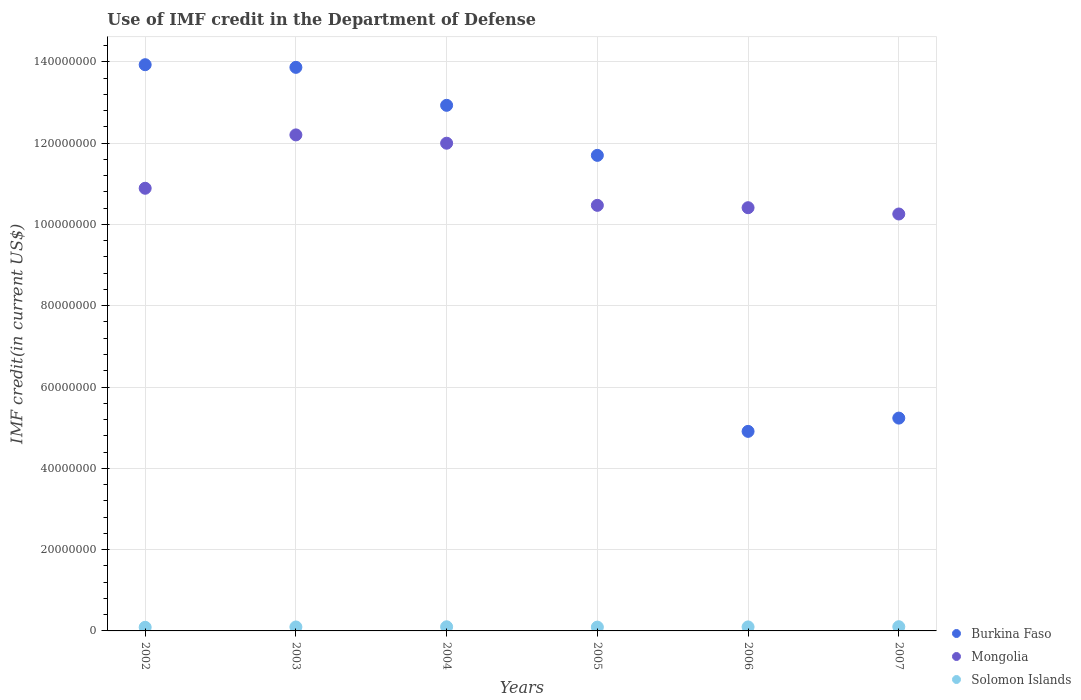What is the IMF credit in the Department of Defense in Solomon Islands in 2005?
Make the answer very short. 9.35e+05. Across all years, what is the maximum IMF credit in the Department of Defense in Burkina Faso?
Make the answer very short. 1.39e+08. Across all years, what is the minimum IMF credit in the Department of Defense in Burkina Faso?
Make the answer very short. 4.91e+07. In which year was the IMF credit in the Department of Defense in Mongolia maximum?
Give a very brief answer. 2003. In which year was the IMF credit in the Department of Defense in Burkina Faso minimum?
Offer a terse response. 2006. What is the total IMF credit in the Department of Defense in Solomon Islands in the graph?
Your answer should be very brief. 5.83e+06. What is the difference between the IMF credit in the Department of Defense in Mongolia in 2003 and that in 2006?
Make the answer very short. 1.79e+07. What is the difference between the IMF credit in the Department of Defense in Mongolia in 2006 and the IMF credit in the Department of Defense in Burkina Faso in 2005?
Your response must be concise. -1.29e+07. What is the average IMF credit in the Department of Defense in Burkina Faso per year?
Provide a succinct answer. 1.04e+08. In the year 2003, what is the difference between the IMF credit in the Department of Defense in Mongolia and IMF credit in the Department of Defense in Burkina Faso?
Offer a terse response. -1.66e+07. What is the ratio of the IMF credit in the Department of Defense in Solomon Islands in 2003 to that in 2007?
Your response must be concise. 0.94. Is the difference between the IMF credit in the Department of Defense in Mongolia in 2006 and 2007 greater than the difference between the IMF credit in the Department of Defense in Burkina Faso in 2006 and 2007?
Provide a short and direct response. Yes. What is the difference between the highest and the second highest IMF credit in the Department of Defense in Mongolia?
Your answer should be very brief. 2.04e+06. What is the difference between the highest and the lowest IMF credit in the Department of Defense in Burkina Faso?
Your response must be concise. 9.02e+07. Is the sum of the IMF credit in the Department of Defense in Solomon Islands in 2003 and 2004 greater than the maximum IMF credit in the Department of Defense in Burkina Faso across all years?
Provide a succinct answer. No. Is the IMF credit in the Department of Defense in Solomon Islands strictly greater than the IMF credit in the Department of Defense in Burkina Faso over the years?
Your answer should be compact. No. How many dotlines are there?
Offer a terse response. 3. How many years are there in the graph?
Make the answer very short. 6. Are the values on the major ticks of Y-axis written in scientific E-notation?
Keep it short and to the point. No. Does the graph contain grids?
Give a very brief answer. Yes. Where does the legend appear in the graph?
Your response must be concise. Bottom right. How many legend labels are there?
Offer a terse response. 3. What is the title of the graph?
Ensure brevity in your answer.  Use of IMF credit in the Department of Defense. Does "Cyprus" appear as one of the legend labels in the graph?
Provide a short and direct response. No. What is the label or title of the X-axis?
Keep it short and to the point. Years. What is the label or title of the Y-axis?
Offer a terse response. IMF credit(in current US$). What is the IMF credit(in current US$) of Burkina Faso in 2002?
Ensure brevity in your answer.  1.39e+08. What is the IMF credit(in current US$) of Mongolia in 2002?
Offer a terse response. 1.09e+08. What is the IMF credit(in current US$) in Solomon Islands in 2002?
Provide a succinct answer. 8.90e+05. What is the IMF credit(in current US$) of Burkina Faso in 2003?
Offer a terse response. 1.39e+08. What is the IMF credit(in current US$) in Mongolia in 2003?
Provide a succinct answer. 1.22e+08. What is the IMF credit(in current US$) in Solomon Islands in 2003?
Your answer should be compact. 9.72e+05. What is the IMF credit(in current US$) of Burkina Faso in 2004?
Make the answer very short. 1.29e+08. What is the IMF credit(in current US$) in Mongolia in 2004?
Your response must be concise. 1.20e+08. What is the IMF credit(in current US$) of Solomon Islands in 2004?
Your response must be concise. 1.02e+06. What is the IMF credit(in current US$) of Burkina Faso in 2005?
Make the answer very short. 1.17e+08. What is the IMF credit(in current US$) of Mongolia in 2005?
Offer a very short reply. 1.05e+08. What is the IMF credit(in current US$) in Solomon Islands in 2005?
Provide a succinct answer. 9.35e+05. What is the IMF credit(in current US$) in Burkina Faso in 2006?
Your response must be concise. 4.91e+07. What is the IMF credit(in current US$) in Mongolia in 2006?
Your answer should be compact. 1.04e+08. What is the IMF credit(in current US$) of Solomon Islands in 2006?
Make the answer very short. 9.84e+05. What is the IMF credit(in current US$) in Burkina Faso in 2007?
Your answer should be compact. 5.24e+07. What is the IMF credit(in current US$) of Mongolia in 2007?
Your answer should be compact. 1.03e+08. What is the IMF credit(in current US$) of Solomon Islands in 2007?
Your answer should be very brief. 1.03e+06. Across all years, what is the maximum IMF credit(in current US$) of Burkina Faso?
Your answer should be compact. 1.39e+08. Across all years, what is the maximum IMF credit(in current US$) in Mongolia?
Your answer should be compact. 1.22e+08. Across all years, what is the maximum IMF credit(in current US$) of Solomon Islands?
Provide a short and direct response. 1.03e+06. Across all years, what is the minimum IMF credit(in current US$) of Burkina Faso?
Provide a short and direct response. 4.91e+07. Across all years, what is the minimum IMF credit(in current US$) in Mongolia?
Your response must be concise. 1.03e+08. Across all years, what is the minimum IMF credit(in current US$) of Solomon Islands?
Give a very brief answer. 8.90e+05. What is the total IMF credit(in current US$) in Burkina Faso in the graph?
Offer a very short reply. 6.26e+08. What is the total IMF credit(in current US$) of Mongolia in the graph?
Provide a short and direct response. 6.62e+08. What is the total IMF credit(in current US$) in Solomon Islands in the graph?
Offer a terse response. 5.83e+06. What is the difference between the IMF credit(in current US$) of Burkina Faso in 2002 and that in 2003?
Ensure brevity in your answer.  6.52e+05. What is the difference between the IMF credit(in current US$) in Mongolia in 2002 and that in 2003?
Provide a succinct answer. -1.31e+07. What is the difference between the IMF credit(in current US$) of Solomon Islands in 2002 and that in 2003?
Offer a very short reply. -8.20e+04. What is the difference between the IMF credit(in current US$) in Burkina Faso in 2002 and that in 2004?
Provide a succinct answer. 9.99e+06. What is the difference between the IMF credit(in current US$) of Mongolia in 2002 and that in 2004?
Make the answer very short. -1.11e+07. What is the difference between the IMF credit(in current US$) in Solomon Islands in 2002 and that in 2004?
Your answer should be compact. -1.26e+05. What is the difference between the IMF credit(in current US$) in Burkina Faso in 2002 and that in 2005?
Your answer should be compact. 2.23e+07. What is the difference between the IMF credit(in current US$) of Mongolia in 2002 and that in 2005?
Ensure brevity in your answer.  4.20e+06. What is the difference between the IMF credit(in current US$) in Solomon Islands in 2002 and that in 2005?
Your answer should be very brief. -4.50e+04. What is the difference between the IMF credit(in current US$) of Burkina Faso in 2002 and that in 2006?
Provide a short and direct response. 9.02e+07. What is the difference between the IMF credit(in current US$) of Mongolia in 2002 and that in 2006?
Ensure brevity in your answer.  4.78e+06. What is the difference between the IMF credit(in current US$) of Solomon Islands in 2002 and that in 2006?
Give a very brief answer. -9.40e+04. What is the difference between the IMF credit(in current US$) of Burkina Faso in 2002 and that in 2007?
Keep it short and to the point. 8.69e+07. What is the difference between the IMF credit(in current US$) in Mongolia in 2002 and that in 2007?
Ensure brevity in your answer.  6.33e+06. What is the difference between the IMF credit(in current US$) in Solomon Islands in 2002 and that in 2007?
Ensure brevity in your answer.  -1.44e+05. What is the difference between the IMF credit(in current US$) of Burkina Faso in 2003 and that in 2004?
Give a very brief answer. 9.34e+06. What is the difference between the IMF credit(in current US$) in Mongolia in 2003 and that in 2004?
Ensure brevity in your answer.  2.04e+06. What is the difference between the IMF credit(in current US$) in Solomon Islands in 2003 and that in 2004?
Make the answer very short. -4.40e+04. What is the difference between the IMF credit(in current US$) of Burkina Faso in 2003 and that in 2005?
Make the answer very short. 2.17e+07. What is the difference between the IMF credit(in current US$) in Mongolia in 2003 and that in 2005?
Your response must be concise. 1.73e+07. What is the difference between the IMF credit(in current US$) in Solomon Islands in 2003 and that in 2005?
Your answer should be very brief. 3.70e+04. What is the difference between the IMF credit(in current US$) of Burkina Faso in 2003 and that in 2006?
Keep it short and to the point. 8.95e+07. What is the difference between the IMF credit(in current US$) in Mongolia in 2003 and that in 2006?
Your response must be concise. 1.79e+07. What is the difference between the IMF credit(in current US$) of Solomon Islands in 2003 and that in 2006?
Your answer should be very brief. -1.20e+04. What is the difference between the IMF credit(in current US$) of Burkina Faso in 2003 and that in 2007?
Offer a very short reply. 8.63e+07. What is the difference between the IMF credit(in current US$) of Mongolia in 2003 and that in 2007?
Keep it short and to the point. 1.95e+07. What is the difference between the IMF credit(in current US$) of Solomon Islands in 2003 and that in 2007?
Make the answer very short. -6.20e+04. What is the difference between the IMF credit(in current US$) of Burkina Faso in 2004 and that in 2005?
Your response must be concise. 1.23e+07. What is the difference between the IMF credit(in current US$) of Mongolia in 2004 and that in 2005?
Provide a succinct answer. 1.53e+07. What is the difference between the IMF credit(in current US$) in Solomon Islands in 2004 and that in 2005?
Your response must be concise. 8.10e+04. What is the difference between the IMF credit(in current US$) of Burkina Faso in 2004 and that in 2006?
Keep it short and to the point. 8.02e+07. What is the difference between the IMF credit(in current US$) of Mongolia in 2004 and that in 2006?
Make the answer very short. 1.59e+07. What is the difference between the IMF credit(in current US$) in Solomon Islands in 2004 and that in 2006?
Keep it short and to the point. 3.20e+04. What is the difference between the IMF credit(in current US$) of Burkina Faso in 2004 and that in 2007?
Keep it short and to the point. 7.69e+07. What is the difference between the IMF credit(in current US$) of Mongolia in 2004 and that in 2007?
Offer a very short reply. 1.74e+07. What is the difference between the IMF credit(in current US$) in Solomon Islands in 2004 and that in 2007?
Provide a succinct answer. -1.80e+04. What is the difference between the IMF credit(in current US$) of Burkina Faso in 2005 and that in 2006?
Provide a succinct answer. 6.79e+07. What is the difference between the IMF credit(in current US$) of Mongolia in 2005 and that in 2006?
Your answer should be compact. 5.81e+05. What is the difference between the IMF credit(in current US$) of Solomon Islands in 2005 and that in 2006?
Your answer should be compact. -4.90e+04. What is the difference between the IMF credit(in current US$) in Burkina Faso in 2005 and that in 2007?
Make the answer very short. 6.46e+07. What is the difference between the IMF credit(in current US$) in Mongolia in 2005 and that in 2007?
Offer a very short reply. 2.13e+06. What is the difference between the IMF credit(in current US$) in Solomon Islands in 2005 and that in 2007?
Keep it short and to the point. -9.90e+04. What is the difference between the IMF credit(in current US$) of Burkina Faso in 2006 and that in 2007?
Offer a terse response. -3.27e+06. What is the difference between the IMF credit(in current US$) of Mongolia in 2006 and that in 2007?
Your response must be concise. 1.55e+06. What is the difference between the IMF credit(in current US$) in Burkina Faso in 2002 and the IMF credit(in current US$) in Mongolia in 2003?
Provide a short and direct response. 1.73e+07. What is the difference between the IMF credit(in current US$) in Burkina Faso in 2002 and the IMF credit(in current US$) in Solomon Islands in 2003?
Ensure brevity in your answer.  1.38e+08. What is the difference between the IMF credit(in current US$) of Mongolia in 2002 and the IMF credit(in current US$) of Solomon Islands in 2003?
Keep it short and to the point. 1.08e+08. What is the difference between the IMF credit(in current US$) in Burkina Faso in 2002 and the IMF credit(in current US$) in Mongolia in 2004?
Provide a succinct answer. 1.93e+07. What is the difference between the IMF credit(in current US$) in Burkina Faso in 2002 and the IMF credit(in current US$) in Solomon Islands in 2004?
Make the answer very short. 1.38e+08. What is the difference between the IMF credit(in current US$) in Mongolia in 2002 and the IMF credit(in current US$) in Solomon Islands in 2004?
Your response must be concise. 1.08e+08. What is the difference between the IMF credit(in current US$) of Burkina Faso in 2002 and the IMF credit(in current US$) of Mongolia in 2005?
Keep it short and to the point. 3.46e+07. What is the difference between the IMF credit(in current US$) in Burkina Faso in 2002 and the IMF credit(in current US$) in Solomon Islands in 2005?
Offer a terse response. 1.38e+08. What is the difference between the IMF credit(in current US$) in Mongolia in 2002 and the IMF credit(in current US$) in Solomon Islands in 2005?
Your answer should be very brief. 1.08e+08. What is the difference between the IMF credit(in current US$) in Burkina Faso in 2002 and the IMF credit(in current US$) in Mongolia in 2006?
Your answer should be compact. 3.52e+07. What is the difference between the IMF credit(in current US$) in Burkina Faso in 2002 and the IMF credit(in current US$) in Solomon Islands in 2006?
Your response must be concise. 1.38e+08. What is the difference between the IMF credit(in current US$) in Mongolia in 2002 and the IMF credit(in current US$) in Solomon Islands in 2006?
Make the answer very short. 1.08e+08. What is the difference between the IMF credit(in current US$) of Burkina Faso in 2002 and the IMF credit(in current US$) of Mongolia in 2007?
Your response must be concise. 3.67e+07. What is the difference between the IMF credit(in current US$) of Burkina Faso in 2002 and the IMF credit(in current US$) of Solomon Islands in 2007?
Offer a very short reply. 1.38e+08. What is the difference between the IMF credit(in current US$) of Mongolia in 2002 and the IMF credit(in current US$) of Solomon Islands in 2007?
Your response must be concise. 1.08e+08. What is the difference between the IMF credit(in current US$) of Burkina Faso in 2003 and the IMF credit(in current US$) of Mongolia in 2004?
Make the answer very short. 1.87e+07. What is the difference between the IMF credit(in current US$) of Burkina Faso in 2003 and the IMF credit(in current US$) of Solomon Islands in 2004?
Make the answer very short. 1.38e+08. What is the difference between the IMF credit(in current US$) in Mongolia in 2003 and the IMF credit(in current US$) in Solomon Islands in 2004?
Keep it short and to the point. 1.21e+08. What is the difference between the IMF credit(in current US$) in Burkina Faso in 2003 and the IMF credit(in current US$) in Mongolia in 2005?
Your answer should be compact. 3.39e+07. What is the difference between the IMF credit(in current US$) in Burkina Faso in 2003 and the IMF credit(in current US$) in Solomon Islands in 2005?
Your answer should be very brief. 1.38e+08. What is the difference between the IMF credit(in current US$) of Mongolia in 2003 and the IMF credit(in current US$) of Solomon Islands in 2005?
Your answer should be very brief. 1.21e+08. What is the difference between the IMF credit(in current US$) of Burkina Faso in 2003 and the IMF credit(in current US$) of Mongolia in 2006?
Your answer should be very brief. 3.45e+07. What is the difference between the IMF credit(in current US$) in Burkina Faso in 2003 and the IMF credit(in current US$) in Solomon Islands in 2006?
Your answer should be very brief. 1.38e+08. What is the difference between the IMF credit(in current US$) in Mongolia in 2003 and the IMF credit(in current US$) in Solomon Islands in 2006?
Offer a terse response. 1.21e+08. What is the difference between the IMF credit(in current US$) in Burkina Faso in 2003 and the IMF credit(in current US$) in Mongolia in 2007?
Provide a short and direct response. 3.61e+07. What is the difference between the IMF credit(in current US$) in Burkina Faso in 2003 and the IMF credit(in current US$) in Solomon Islands in 2007?
Provide a short and direct response. 1.38e+08. What is the difference between the IMF credit(in current US$) of Mongolia in 2003 and the IMF credit(in current US$) of Solomon Islands in 2007?
Offer a terse response. 1.21e+08. What is the difference between the IMF credit(in current US$) in Burkina Faso in 2004 and the IMF credit(in current US$) in Mongolia in 2005?
Your answer should be very brief. 2.46e+07. What is the difference between the IMF credit(in current US$) of Burkina Faso in 2004 and the IMF credit(in current US$) of Solomon Islands in 2005?
Offer a terse response. 1.28e+08. What is the difference between the IMF credit(in current US$) in Mongolia in 2004 and the IMF credit(in current US$) in Solomon Islands in 2005?
Provide a short and direct response. 1.19e+08. What is the difference between the IMF credit(in current US$) of Burkina Faso in 2004 and the IMF credit(in current US$) of Mongolia in 2006?
Offer a very short reply. 2.52e+07. What is the difference between the IMF credit(in current US$) in Burkina Faso in 2004 and the IMF credit(in current US$) in Solomon Islands in 2006?
Provide a short and direct response. 1.28e+08. What is the difference between the IMF credit(in current US$) of Mongolia in 2004 and the IMF credit(in current US$) of Solomon Islands in 2006?
Keep it short and to the point. 1.19e+08. What is the difference between the IMF credit(in current US$) in Burkina Faso in 2004 and the IMF credit(in current US$) in Mongolia in 2007?
Make the answer very short. 2.67e+07. What is the difference between the IMF credit(in current US$) of Burkina Faso in 2004 and the IMF credit(in current US$) of Solomon Islands in 2007?
Provide a short and direct response. 1.28e+08. What is the difference between the IMF credit(in current US$) of Mongolia in 2004 and the IMF credit(in current US$) of Solomon Islands in 2007?
Your response must be concise. 1.19e+08. What is the difference between the IMF credit(in current US$) of Burkina Faso in 2005 and the IMF credit(in current US$) of Mongolia in 2006?
Provide a short and direct response. 1.29e+07. What is the difference between the IMF credit(in current US$) of Burkina Faso in 2005 and the IMF credit(in current US$) of Solomon Islands in 2006?
Offer a terse response. 1.16e+08. What is the difference between the IMF credit(in current US$) of Mongolia in 2005 and the IMF credit(in current US$) of Solomon Islands in 2006?
Offer a terse response. 1.04e+08. What is the difference between the IMF credit(in current US$) of Burkina Faso in 2005 and the IMF credit(in current US$) of Mongolia in 2007?
Your answer should be very brief. 1.44e+07. What is the difference between the IMF credit(in current US$) of Burkina Faso in 2005 and the IMF credit(in current US$) of Solomon Islands in 2007?
Offer a very short reply. 1.16e+08. What is the difference between the IMF credit(in current US$) in Mongolia in 2005 and the IMF credit(in current US$) in Solomon Islands in 2007?
Provide a succinct answer. 1.04e+08. What is the difference between the IMF credit(in current US$) of Burkina Faso in 2006 and the IMF credit(in current US$) of Mongolia in 2007?
Offer a very short reply. -5.35e+07. What is the difference between the IMF credit(in current US$) in Burkina Faso in 2006 and the IMF credit(in current US$) in Solomon Islands in 2007?
Make the answer very short. 4.81e+07. What is the difference between the IMF credit(in current US$) of Mongolia in 2006 and the IMF credit(in current US$) of Solomon Islands in 2007?
Your response must be concise. 1.03e+08. What is the average IMF credit(in current US$) in Burkina Faso per year?
Offer a very short reply. 1.04e+08. What is the average IMF credit(in current US$) in Mongolia per year?
Your answer should be compact. 1.10e+08. What is the average IMF credit(in current US$) in Solomon Islands per year?
Keep it short and to the point. 9.72e+05. In the year 2002, what is the difference between the IMF credit(in current US$) of Burkina Faso and IMF credit(in current US$) of Mongolia?
Give a very brief answer. 3.04e+07. In the year 2002, what is the difference between the IMF credit(in current US$) in Burkina Faso and IMF credit(in current US$) in Solomon Islands?
Keep it short and to the point. 1.38e+08. In the year 2002, what is the difference between the IMF credit(in current US$) in Mongolia and IMF credit(in current US$) in Solomon Islands?
Give a very brief answer. 1.08e+08. In the year 2003, what is the difference between the IMF credit(in current US$) of Burkina Faso and IMF credit(in current US$) of Mongolia?
Your response must be concise. 1.66e+07. In the year 2003, what is the difference between the IMF credit(in current US$) in Burkina Faso and IMF credit(in current US$) in Solomon Islands?
Give a very brief answer. 1.38e+08. In the year 2003, what is the difference between the IMF credit(in current US$) of Mongolia and IMF credit(in current US$) of Solomon Islands?
Keep it short and to the point. 1.21e+08. In the year 2004, what is the difference between the IMF credit(in current US$) in Burkina Faso and IMF credit(in current US$) in Mongolia?
Make the answer very short. 9.32e+06. In the year 2004, what is the difference between the IMF credit(in current US$) of Burkina Faso and IMF credit(in current US$) of Solomon Islands?
Offer a terse response. 1.28e+08. In the year 2004, what is the difference between the IMF credit(in current US$) of Mongolia and IMF credit(in current US$) of Solomon Islands?
Your answer should be compact. 1.19e+08. In the year 2005, what is the difference between the IMF credit(in current US$) of Burkina Faso and IMF credit(in current US$) of Mongolia?
Your response must be concise. 1.23e+07. In the year 2005, what is the difference between the IMF credit(in current US$) of Burkina Faso and IMF credit(in current US$) of Solomon Islands?
Provide a succinct answer. 1.16e+08. In the year 2005, what is the difference between the IMF credit(in current US$) in Mongolia and IMF credit(in current US$) in Solomon Islands?
Give a very brief answer. 1.04e+08. In the year 2006, what is the difference between the IMF credit(in current US$) in Burkina Faso and IMF credit(in current US$) in Mongolia?
Keep it short and to the point. -5.50e+07. In the year 2006, what is the difference between the IMF credit(in current US$) in Burkina Faso and IMF credit(in current US$) in Solomon Islands?
Your answer should be very brief. 4.81e+07. In the year 2006, what is the difference between the IMF credit(in current US$) of Mongolia and IMF credit(in current US$) of Solomon Islands?
Offer a terse response. 1.03e+08. In the year 2007, what is the difference between the IMF credit(in current US$) in Burkina Faso and IMF credit(in current US$) in Mongolia?
Your answer should be very brief. -5.02e+07. In the year 2007, what is the difference between the IMF credit(in current US$) of Burkina Faso and IMF credit(in current US$) of Solomon Islands?
Your answer should be very brief. 5.13e+07. In the year 2007, what is the difference between the IMF credit(in current US$) of Mongolia and IMF credit(in current US$) of Solomon Islands?
Keep it short and to the point. 1.02e+08. What is the ratio of the IMF credit(in current US$) in Burkina Faso in 2002 to that in 2003?
Provide a succinct answer. 1. What is the ratio of the IMF credit(in current US$) of Mongolia in 2002 to that in 2003?
Your answer should be very brief. 0.89. What is the ratio of the IMF credit(in current US$) of Solomon Islands in 2002 to that in 2003?
Provide a short and direct response. 0.92. What is the ratio of the IMF credit(in current US$) in Burkina Faso in 2002 to that in 2004?
Keep it short and to the point. 1.08. What is the ratio of the IMF credit(in current US$) in Mongolia in 2002 to that in 2004?
Provide a short and direct response. 0.91. What is the ratio of the IMF credit(in current US$) in Solomon Islands in 2002 to that in 2004?
Ensure brevity in your answer.  0.88. What is the ratio of the IMF credit(in current US$) of Burkina Faso in 2002 to that in 2005?
Make the answer very short. 1.19. What is the ratio of the IMF credit(in current US$) in Mongolia in 2002 to that in 2005?
Your answer should be compact. 1.04. What is the ratio of the IMF credit(in current US$) in Solomon Islands in 2002 to that in 2005?
Ensure brevity in your answer.  0.95. What is the ratio of the IMF credit(in current US$) in Burkina Faso in 2002 to that in 2006?
Give a very brief answer. 2.84. What is the ratio of the IMF credit(in current US$) in Mongolia in 2002 to that in 2006?
Keep it short and to the point. 1.05. What is the ratio of the IMF credit(in current US$) in Solomon Islands in 2002 to that in 2006?
Make the answer very short. 0.9. What is the ratio of the IMF credit(in current US$) of Burkina Faso in 2002 to that in 2007?
Ensure brevity in your answer.  2.66. What is the ratio of the IMF credit(in current US$) in Mongolia in 2002 to that in 2007?
Provide a succinct answer. 1.06. What is the ratio of the IMF credit(in current US$) of Solomon Islands in 2002 to that in 2007?
Your answer should be compact. 0.86. What is the ratio of the IMF credit(in current US$) in Burkina Faso in 2003 to that in 2004?
Make the answer very short. 1.07. What is the ratio of the IMF credit(in current US$) in Mongolia in 2003 to that in 2004?
Your answer should be compact. 1.02. What is the ratio of the IMF credit(in current US$) in Solomon Islands in 2003 to that in 2004?
Ensure brevity in your answer.  0.96. What is the ratio of the IMF credit(in current US$) of Burkina Faso in 2003 to that in 2005?
Keep it short and to the point. 1.19. What is the ratio of the IMF credit(in current US$) of Mongolia in 2003 to that in 2005?
Provide a succinct answer. 1.17. What is the ratio of the IMF credit(in current US$) of Solomon Islands in 2003 to that in 2005?
Your answer should be compact. 1.04. What is the ratio of the IMF credit(in current US$) in Burkina Faso in 2003 to that in 2006?
Keep it short and to the point. 2.82. What is the ratio of the IMF credit(in current US$) in Mongolia in 2003 to that in 2006?
Give a very brief answer. 1.17. What is the ratio of the IMF credit(in current US$) in Solomon Islands in 2003 to that in 2006?
Ensure brevity in your answer.  0.99. What is the ratio of the IMF credit(in current US$) of Burkina Faso in 2003 to that in 2007?
Provide a succinct answer. 2.65. What is the ratio of the IMF credit(in current US$) of Mongolia in 2003 to that in 2007?
Your response must be concise. 1.19. What is the ratio of the IMF credit(in current US$) in Burkina Faso in 2004 to that in 2005?
Provide a succinct answer. 1.11. What is the ratio of the IMF credit(in current US$) of Mongolia in 2004 to that in 2005?
Offer a very short reply. 1.15. What is the ratio of the IMF credit(in current US$) in Solomon Islands in 2004 to that in 2005?
Provide a succinct answer. 1.09. What is the ratio of the IMF credit(in current US$) in Burkina Faso in 2004 to that in 2006?
Offer a terse response. 2.63. What is the ratio of the IMF credit(in current US$) in Mongolia in 2004 to that in 2006?
Offer a terse response. 1.15. What is the ratio of the IMF credit(in current US$) of Solomon Islands in 2004 to that in 2006?
Make the answer very short. 1.03. What is the ratio of the IMF credit(in current US$) of Burkina Faso in 2004 to that in 2007?
Provide a short and direct response. 2.47. What is the ratio of the IMF credit(in current US$) in Mongolia in 2004 to that in 2007?
Ensure brevity in your answer.  1.17. What is the ratio of the IMF credit(in current US$) of Solomon Islands in 2004 to that in 2007?
Your answer should be compact. 0.98. What is the ratio of the IMF credit(in current US$) in Burkina Faso in 2005 to that in 2006?
Your answer should be compact. 2.38. What is the ratio of the IMF credit(in current US$) in Mongolia in 2005 to that in 2006?
Make the answer very short. 1.01. What is the ratio of the IMF credit(in current US$) in Solomon Islands in 2005 to that in 2006?
Your answer should be very brief. 0.95. What is the ratio of the IMF credit(in current US$) of Burkina Faso in 2005 to that in 2007?
Your answer should be very brief. 2.23. What is the ratio of the IMF credit(in current US$) in Mongolia in 2005 to that in 2007?
Offer a very short reply. 1.02. What is the ratio of the IMF credit(in current US$) of Solomon Islands in 2005 to that in 2007?
Provide a short and direct response. 0.9. What is the ratio of the IMF credit(in current US$) in Burkina Faso in 2006 to that in 2007?
Keep it short and to the point. 0.94. What is the ratio of the IMF credit(in current US$) in Mongolia in 2006 to that in 2007?
Ensure brevity in your answer.  1.02. What is the ratio of the IMF credit(in current US$) in Solomon Islands in 2006 to that in 2007?
Give a very brief answer. 0.95. What is the difference between the highest and the second highest IMF credit(in current US$) of Burkina Faso?
Your answer should be very brief. 6.52e+05. What is the difference between the highest and the second highest IMF credit(in current US$) in Mongolia?
Your answer should be compact. 2.04e+06. What is the difference between the highest and the second highest IMF credit(in current US$) of Solomon Islands?
Keep it short and to the point. 1.80e+04. What is the difference between the highest and the lowest IMF credit(in current US$) of Burkina Faso?
Offer a terse response. 9.02e+07. What is the difference between the highest and the lowest IMF credit(in current US$) in Mongolia?
Offer a terse response. 1.95e+07. What is the difference between the highest and the lowest IMF credit(in current US$) of Solomon Islands?
Offer a very short reply. 1.44e+05. 